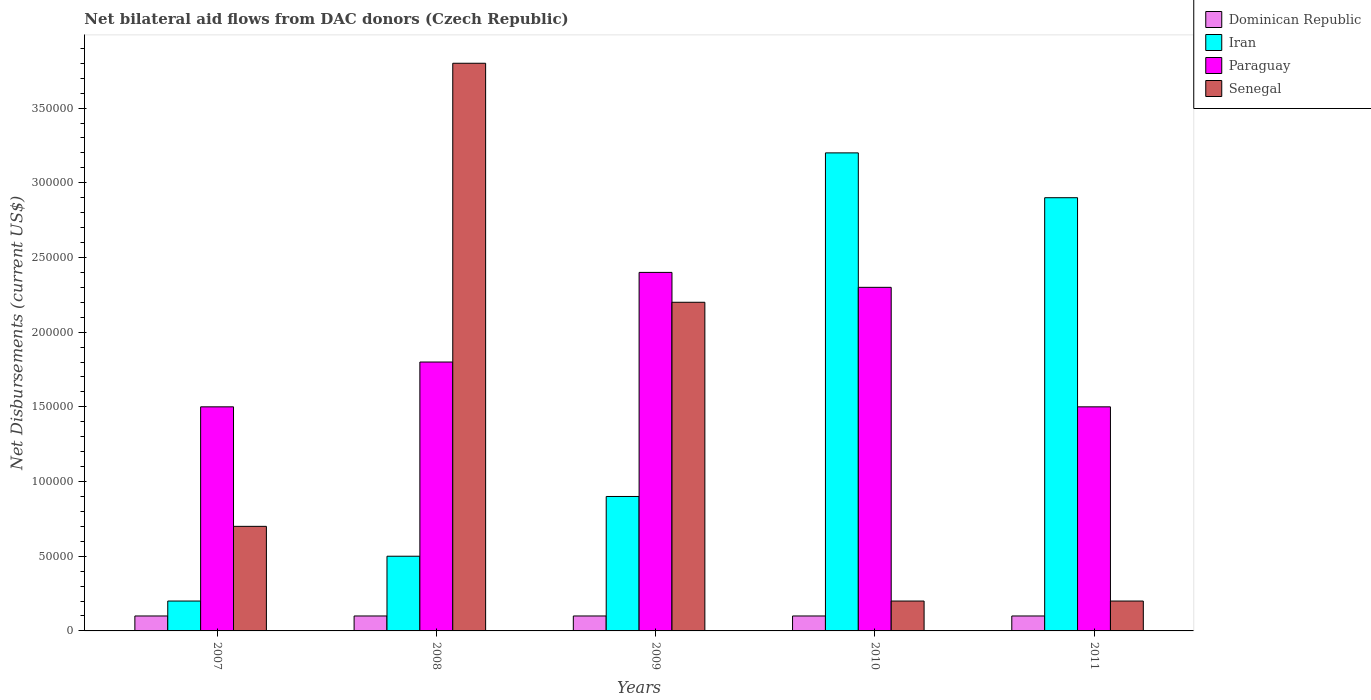How many groups of bars are there?
Your answer should be very brief. 5. How many bars are there on the 4th tick from the left?
Your answer should be very brief. 4. What is the label of the 4th group of bars from the left?
Keep it short and to the point. 2010. What is the net bilateral aid flows in Paraguay in 2009?
Your response must be concise. 2.40e+05. Across all years, what is the maximum net bilateral aid flows in Paraguay?
Provide a short and direct response. 2.40e+05. Across all years, what is the minimum net bilateral aid flows in Paraguay?
Make the answer very short. 1.50e+05. In which year was the net bilateral aid flows in Paraguay minimum?
Your response must be concise. 2007. What is the total net bilateral aid flows in Iran in the graph?
Make the answer very short. 7.70e+05. What is the difference between the net bilateral aid flows in Paraguay in 2008 and that in 2010?
Offer a terse response. -5.00e+04. What is the difference between the net bilateral aid flows in Iran in 2008 and the net bilateral aid flows in Senegal in 2009?
Give a very brief answer. -1.70e+05. What is the average net bilateral aid flows in Paraguay per year?
Make the answer very short. 1.90e+05. In the year 2009, what is the difference between the net bilateral aid flows in Iran and net bilateral aid flows in Dominican Republic?
Your answer should be compact. 8.00e+04. What is the ratio of the net bilateral aid flows in Paraguay in 2007 to that in 2011?
Provide a succinct answer. 1. Is the net bilateral aid flows in Paraguay in 2008 less than that in 2009?
Ensure brevity in your answer.  Yes. Is the difference between the net bilateral aid flows in Iran in 2008 and 2011 greater than the difference between the net bilateral aid flows in Dominican Republic in 2008 and 2011?
Your response must be concise. No. What is the difference between the highest and the lowest net bilateral aid flows in Senegal?
Provide a succinct answer. 3.60e+05. Is it the case that in every year, the sum of the net bilateral aid flows in Iran and net bilateral aid flows in Dominican Republic is greater than the sum of net bilateral aid flows in Paraguay and net bilateral aid flows in Senegal?
Offer a very short reply. Yes. What does the 2nd bar from the left in 2011 represents?
Offer a terse response. Iran. What does the 2nd bar from the right in 2007 represents?
Your answer should be compact. Paraguay. Is it the case that in every year, the sum of the net bilateral aid flows in Senegal and net bilateral aid flows in Paraguay is greater than the net bilateral aid flows in Iran?
Give a very brief answer. No. How many bars are there?
Provide a short and direct response. 20. Are all the bars in the graph horizontal?
Ensure brevity in your answer.  No. What is the difference between two consecutive major ticks on the Y-axis?
Give a very brief answer. 5.00e+04. Does the graph contain any zero values?
Provide a succinct answer. No. Does the graph contain grids?
Offer a very short reply. No. Where does the legend appear in the graph?
Your response must be concise. Top right. How are the legend labels stacked?
Your answer should be very brief. Vertical. What is the title of the graph?
Your response must be concise. Net bilateral aid flows from DAC donors (Czech Republic). What is the label or title of the Y-axis?
Your response must be concise. Net Disbursements (current US$). What is the Net Disbursements (current US$) in Dominican Republic in 2007?
Keep it short and to the point. 10000. What is the Net Disbursements (current US$) of Paraguay in 2007?
Your answer should be compact. 1.50e+05. What is the Net Disbursements (current US$) in Senegal in 2007?
Offer a terse response. 7.00e+04. What is the Net Disbursements (current US$) in Iran in 2008?
Make the answer very short. 5.00e+04. What is the Net Disbursements (current US$) of Dominican Republic in 2009?
Offer a very short reply. 10000. What is the Net Disbursements (current US$) in Paraguay in 2009?
Offer a terse response. 2.40e+05. What is the Net Disbursements (current US$) of Senegal in 2009?
Give a very brief answer. 2.20e+05. What is the Net Disbursements (current US$) in Iran in 2010?
Your answer should be very brief. 3.20e+05. What is the Net Disbursements (current US$) in Paraguay in 2010?
Provide a short and direct response. 2.30e+05. What is the Net Disbursements (current US$) of Iran in 2011?
Offer a very short reply. 2.90e+05. What is the Net Disbursements (current US$) in Senegal in 2011?
Your answer should be very brief. 2.00e+04. Across all years, what is the maximum Net Disbursements (current US$) of Senegal?
Your answer should be very brief. 3.80e+05. Across all years, what is the minimum Net Disbursements (current US$) in Iran?
Ensure brevity in your answer.  2.00e+04. Across all years, what is the minimum Net Disbursements (current US$) in Paraguay?
Your answer should be very brief. 1.50e+05. What is the total Net Disbursements (current US$) of Iran in the graph?
Provide a succinct answer. 7.70e+05. What is the total Net Disbursements (current US$) in Paraguay in the graph?
Provide a succinct answer. 9.50e+05. What is the total Net Disbursements (current US$) of Senegal in the graph?
Offer a terse response. 7.10e+05. What is the difference between the Net Disbursements (current US$) of Dominican Republic in 2007 and that in 2008?
Keep it short and to the point. 0. What is the difference between the Net Disbursements (current US$) in Senegal in 2007 and that in 2008?
Your answer should be compact. -3.10e+05. What is the difference between the Net Disbursements (current US$) of Iran in 2007 and that in 2009?
Your answer should be compact. -7.00e+04. What is the difference between the Net Disbursements (current US$) of Paraguay in 2007 and that in 2009?
Your answer should be very brief. -9.00e+04. What is the difference between the Net Disbursements (current US$) in Senegal in 2007 and that in 2009?
Your answer should be compact. -1.50e+05. What is the difference between the Net Disbursements (current US$) in Iran in 2007 and that in 2010?
Your response must be concise. -3.00e+05. What is the difference between the Net Disbursements (current US$) in Dominican Republic in 2007 and that in 2011?
Give a very brief answer. 0. What is the difference between the Net Disbursements (current US$) of Iran in 2008 and that in 2009?
Give a very brief answer. -4.00e+04. What is the difference between the Net Disbursements (current US$) of Paraguay in 2008 and that in 2009?
Ensure brevity in your answer.  -6.00e+04. What is the difference between the Net Disbursements (current US$) in Senegal in 2008 and that in 2009?
Your answer should be compact. 1.60e+05. What is the difference between the Net Disbursements (current US$) in Iran in 2008 and that in 2010?
Provide a succinct answer. -2.70e+05. What is the difference between the Net Disbursements (current US$) in Senegal in 2008 and that in 2011?
Keep it short and to the point. 3.60e+05. What is the difference between the Net Disbursements (current US$) in Iran in 2009 and that in 2010?
Ensure brevity in your answer.  -2.30e+05. What is the difference between the Net Disbursements (current US$) in Dominican Republic in 2009 and that in 2011?
Ensure brevity in your answer.  0. What is the difference between the Net Disbursements (current US$) in Iran in 2009 and that in 2011?
Offer a terse response. -2.00e+05. What is the difference between the Net Disbursements (current US$) in Paraguay in 2009 and that in 2011?
Offer a terse response. 9.00e+04. What is the difference between the Net Disbursements (current US$) of Senegal in 2009 and that in 2011?
Ensure brevity in your answer.  2.00e+05. What is the difference between the Net Disbursements (current US$) in Dominican Republic in 2010 and that in 2011?
Make the answer very short. 0. What is the difference between the Net Disbursements (current US$) in Iran in 2010 and that in 2011?
Ensure brevity in your answer.  3.00e+04. What is the difference between the Net Disbursements (current US$) in Dominican Republic in 2007 and the Net Disbursements (current US$) in Paraguay in 2008?
Offer a terse response. -1.70e+05. What is the difference between the Net Disbursements (current US$) of Dominican Republic in 2007 and the Net Disbursements (current US$) of Senegal in 2008?
Make the answer very short. -3.70e+05. What is the difference between the Net Disbursements (current US$) in Iran in 2007 and the Net Disbursements (current US$) in Senegal in 2008?
Your answer should be very brief. -3.60e+05. What is the difference between the Net Disbursements (current US$) of Dominican Republic in 2007 and the Net Disbursements (current US$) of Iran in 2009?
Offer a terse response. -8.00e+04. What is the difference between the Net Disbursements (current US$) of Dominican Republic in 2007 and the Net Disbursements (current US$) of Paraguay in 2009?
Give a very brief answer. -2.30e+05. What is the difference between the Net Disbursements (current US$) of Dominican Republic in 2007 and the Net Disbursements (current US$) of Senegal in 2009?
Offer a terse response. -2.10e+05. What is the difference between the Net Disbursements (current US$) in Iran in 2007 and the Net Disbursements (current US$) in Senegal in 2009?
Your response must be concise. -2.00e+05. What is the difference between the Net Disbursements (current US$) of Paraguay in 2007 and the Net Disbursements (current US$) of Senegal in 2009?
Give a very brief answer. -7.00e+04. What is the difference between the Net Disbursements (current US$) in Dominican Republic in 2007 and the Net Disbursements (current US$) in Iran in 2010?
Your answer should be compact. -3.10e+05. What is the difference between the Net Disbursements (current US$) of Dominican Republic in 2007 and the Net Disbursements (current US$) of Paraguay in 2010?
Keep it short and to the point. -2.20e+05. What is the difference between the Net Disbursements (current US$) in Iran in 2007 and the Net Disbursements (current US$) in Senegal in 2010?
Provide a succinct answer. 0. What is the difference between the Net Disbursements (current US$) in Paraguay in 2007 and the Net Disbursements (current US$) in Senegal in 2010?
Your answer should be very brief. 1.30e+05. What is the difference between the Net Disbursements (current US$) of Dominican Republic in 2007 and the Net Disbursements (current US$) of Iran in 2011?
Ensure brevity in your answer.  -2.80e+05. What is the difference between the Net Disbursements (current US$) in Dominican Republic in 2007 and the Net Disbursements (current US$) in Paraguay in 2011?
Make the answer very short. -1.40e+05. What is the difference between the Net Disbursements (current US$) in Dominican Republic in 2007 and the Net Disbursements (current US$) in Senegal in 2011?
Give a very brief answer. -10000. What is the difference between the Net Disbursements (current US$) of Iran in 2007 and the Net Disbursements (current US$) of Paraguay in 2011?
Give a very brief answer. -1.30e+05. What is the difference between the Net Disbursements (current US$) in Paraguay in 2007 and the Net Disbursements (current US$) in Senegal in 2011?
Your answer should be very brief. 1.30e+05. What is the difference between the Net Disbursements (current US$) in Dominican Republic in 2008 and the Net Disbursements (current US$) in Iran in 2009?
Your answer should be compact. -8.00e+04. What is the difference between the Net Disbursements (current US$) in Dominican Republic in 2008 and the Net Disbursements (current US$) in Senegal in 2009?
Your answer should be very brief. -2.10e+05. What is the difference between the Net Disbursements (current US$) in Iran in 2008 and the Net Disbursements (current US$) in Paraguay in 2009?
Your answer should be compact. -1.90e+05. What is the difference between the Net Disbursements (current US$) in Dominican Republic in 2008 and the Net Disbursements (current US$) in Iran in 2010?
Ensure brevity in your answer.  -3.10e+05. What is the difference between the Net Disbursements (current US$) of Dominican Republic in 2008 and the Net Disbursements (current US$) of Paraguay in 2010?
Keep it short and to the point. -2.20e+05. What is the difference between the Net Disbursements (current US$) of Dominican Republic in 2008 and the Net Disbursements (current US$) of Senegal in 2010?
Provide a succinct answer. -10000. What is the difference between the Net Disbursements (current US$) in Iran in 2008 and the Net Disbursements (current US$) in Paraguay in 2010?
Your response must be concise. -1.80e+05. What is the difference between the Net Disbursements (current US$) in Paraguay in 2008 and the Net Disbursements (current US$) in Senegal in 2010?
Provide a succinct answer. 1.60e+05. What is the difference between the Net Disbursements (current US$) of Dominican Republic in 2008 and the Net Disbursements (current US$) of Iran in 2011?
Your answer should be compact. -2.80e+05. What is the difference between the Net Disbursements (current US$) of Dominican Republic in 2008 and the Net Disbursements (current US$) of Paraguay in 2011?
Provide a succinct answer. -1.40e+05. What is the difference between the Net Disbursements (current US$) of Iran in 2008 and the Net Disbursements (current US$) of Paraguay in 2011?
Give a very brief answer. -1.00e+05. What is the difference between the Net Disbursements (current US$) of Iran in 2008 and the Net Disbursements (current US$) of Senegal in 2011?
Ensure brevity in your answer.  3.00e+04. What is the difference between the Net Disbursements (current US$) in Paraguay in 2008 and the Net Disbursements (current US$) in Senegal in 2011?
Ensure brevity in your answer.  1.60e+05. What is the difference between the Net Disbursements (current US$) in Dominican Republic in 2009 and the Net Disbursements (current US$) in Iran in 2010?
Your answer should be compact. -3.10e+05. What is the difference between the Net Disbursements (current US$) of Dominican Republic in 2009 and the Net Disbursements (current US$) of Paraguay in 2010?
Ensure brevity in your answer.  -2.20e+05. What is the difference between the Net Disbursements (current US$) in Dominican Republic in 2009 and the Net Disbursements (current US$) in Senegal in 2010?
Your answer should be very brief. -10000. What is the difference between the Net Disbursements (current US$) in Iran in 2009 and the Net Disbursements (current US$) in Senegal in 2010?
Your answer should be compact. 7.00e+04. What is the difference between the Net Disbursements (current US$) in Dominican Republic in 2009 and the Net Disbursements (current US$) in Iran in 2011?
Provide a short and direct response. -2.80e+05. What is the difference between the Net Disbursements (current US$) in Dominican Republic in 2009 and the Net Disbursements (current US$) in Paraguay in 2011?
Make the answer very short. -1.40e+05. What is the difference between the Net Disbursements (current US$) in Dominican Republic in 2009 and the Net Disbursements (current US$) in Senegal in 2011?
Ensure brevity in your answer.  -10000. What is the difference between the Net Disbursements (current US$) in Iran in 2009 and the Net Disbursements (current US$) in Senegal in 2011?
Offer a very short reply. 7.00e+04. What is the difference between the Net Disbursements (current US$) of Paraguay in 2009 and the Net Disbursements (current US$) of Senegal in 2011?
Offer a very short reply. 2.20e+05. What is the difference between the Net Disbursements (current US$) of Dominican Republic in 2010 and the Net Disbursements (current US$) of Iran in 2011?
Keep it short and to the point. -2.80e+05. What is the difference between the Net Disbursements (current US$) of Dominican Republic in 2010 and the Net Disbursements (current US$) of Senegal in 2011?
Keep it short and to the point. -10000. What is the difference between the Net Disbursements (current US$) of Iran in 2010 and the Net Disbursements (current US$) of Paraguay in 2011?
Your response must be concise. 1.70e+05. What is the difference between the Net Disbursements (current US$) of Paraguay in 2010 and the Net Disbursements (current US$) of Senegal in 2011?
Offer a terse response. 2.10e+05. What is the average Net Disbursements (current US$) of Dominican Republic per year?
Ensure brevity in your answer.  10000. What is the average Net Disbursements (current US$) in Iran per year?
Make the answer very short. 1.54e+05. What is the average Net Disbursements (current US$) in Paraguay per year?
Provide a short and direct response. 1.90e+05. What is the average Net Disbursements (current US$) in Senegal per year?
Ensure brevity in your answer.  1.42e+05. In the year 2007, what is the difference between the Net Disbursements (current US$) in Dominican Republic and Net Disbursements (current US$) in Iran?
Your response must be concise. -10000. In the year 2007, what is the difference between the Net Disbursements (current US$) of Dominican Republic and Net Disbursements (current US$) of Senegal?
Make the answer very short. -6.00e+04. In the year 2007, what is the difference between the Net Disbursements (current US$) of Iran and Net Disbursements (current US$) of Paraguay?
Provide a short and direct response. -1.30e+05. In the year 2007, what is the difference between the Net Disbursements (current US$) of Iran and Net Disbursements (current US$) of Senegal?
Your answer should be very brief. -5.00e+04. In the year 2008, what is the difference between the Net Disbursements (current US$) of Dominican Republic and Net Disbursements (current US$) of Paraguay?
Keep it short and to the point. -1.70e+05. In the year 2008, what is the difference between the Net Disbursements (current US$) of Dominican Republic and Net Disbursements (current US$) of Senegal?
Make the answer very short. -3.70e+05. In the year 2008, what is the difference between the Net Disbursements (current US$) in Iran and Net Disbursements (current US$) in Paraguay?
Provide a succinct answer. -1.30e+05. In the year 2008, what is the difference between the Net Disbursements (current US$) of Iran and Net Disbursements (current US$) of Senegal?
Provide a succinct answer. -3.30e+05. In the year 2008, what is the difference between the Net Disbursements (current US$) in Paraguay and Net Disbursements (current US$) in Senegal?
Give a very brief answer. -2.00e+05. In the year 2009, what is the difference between the Net Disbursements (current US$) in Dominican Republic and Net Disbursements (current US$) in Paraguay?
Give a very brief answer. -2.30e+05. In the year 2009, what is the difference between the Net Disbursements (current US$) in Iran and Net Disbursements (current US$) in Paraguay?
Offer a very short reply. -1.50e+05. In the year 2009, what is the difference between the Net Disbursements (current US$) in Iran and Net Disbursements (current US$) in Senegal?
Your answer should be compact. -1.30e+05. In the year 2009, what is the difference between the Net Disbursements (current US$) of Paraguay and Net Disbursements (current US$) of Senegal?
Offer a very short reply. 2.00e+04. In the year 2010, what is the difference between the Net Disbursements (current US$) in Dominican Republic and Net Disbursements (current US$) in Iran?
Ensure brevity in your answer.  -3.10e+05. In the year 2010, what is the difference between the Net Disbursements (current US$) of Dominican Republic and Net Disbursements (current US$) of Paraguay?
Keep it short and to the point. -2.20e+05. In the year 2010, what is the difference between the Net Disbursements (current US$) in Dominican Republic and Net Disbursements (current US$) in Senegal?
Ensure brevity in your answer.  -10000. In the year 2010, what is the difference between the Net Disbursements (current US$) in Iran and Net Disbursements (current US$) in Senegal?
Ensure brevity in your answer.  3.00e+05. In the year 2010, what is the difference between the Net Disbursements (current US$) of Paraguay and Net Disbursements (current US$) of Senegal?
Your answer should be compact. 2.10e+05. In the year 2011, what is the difference between the Net Disbursements (current US$) of Dominican Republic and Net Disbursements (current US$) of Iran?
Your response must be concise. -2.80e+05. In the year 2011, what is the difference between the Net Disbursements (current US$) in Dominican Republic and Net Disbursements (current US$) in Senegal?
Give a very brief answer. -10000. In the year 2011, what is the difference between the Net Disbursements (current US$) of Iran and Net Disbursements (current US$) of Paraguay?
Your answer should be very brief. 1.40e+05. In the year 2011, what is the difference between the Net Disbursements (current US$) of Iran and Net Disbursements (current US$) of Senegal?
Provide a succinct answer. 2.70e+05. In the year 2011, what is the difference between the Net Disbursements (current US$) in Paraguay and Net Disbursements (current US$) in Senegal?
Keep it short and to the point. 1.30e+05. What is the ratio of the Net Disbursements (current US$) of Paraguay in 2007 to that in 2008?
Make the answer very short. 0.83. What is the ratio of the Net Disbursements (current US$) in Senegal in 2007 to that in 2008?
Provide a short and direct response. 0.18. What is the ratio of the Net Disbursements (current US$) of Dominican Republic in 2007 to that in 2009?
Keep it short and to the point. 1. What is the ratio of the Net Disbursements (current US$) in Iran in 2007 to that in 2009?
Make the answer very short. 0.22. What is the ratio of the Net Disbursements (current US$) of Senegal in 2007 to that in 2009?
Your response must be concise. 0.32. What is the ratio of the Net Disbursements (current US$) in Iran in 2007 to that in 2010?
Offer a terse response. 0.06. What is the ratio of the Net Disbursements (current US$) in Paraguay in 2007 to that in 2010?
Offer a terse response. 0.65. What is the ratio of the Net Disbursements (current US$) of Dominican Republic in 2007 to that in 2011?
Your answer should be very brief. 1. What is the ratio of the Net Disbursements (current US$) in Iran in 2007 to that in 2011?
Your answer should be very brief. 0.07. What is the ratio of the Net Disbursements (current US$) in Paraguay in 2007 to that in 2011?
Your response must be concise. 1. What is the ratio of the Net Disbursements (current US$) in Dominican Republic in 2008 to that in 2009?
Your response must be concise. 1. What is the ratio of the Net Disbursements (current US$) in Iran in 2008 to that in 2009?
Your response must be concise. 0.56. What is the ratio of the Net Disbursements (current US$) of Paraguay in 2008 to that in 2009?
Offer a terse response. 0.75. What is the ratio of the Net Disbursements (current US$) in Senegal in 2008 to that in 2009?
Your response must be concise. 1.73. What is the ratio of the Net Disbursements (current US$) in Dominican Republic in 2008 to that in 2010?
Give a very brief answer. 1. What is the ratio of the Net Disbursements (current US$) of Iran in 2008 to that in 2010?
Offer a terse response. 0.16. What is the ratio of the Net Disbursements (current US$) in Paraguay in 2008 to that in 2010?
Provide a short and direct response. 0.78. What is the ratio of the Net Disbursements (current US$) of Senegal in 2008 to that in 2010?
Provide a short and direct response. 19. What is the ratio of the Net Disbursements (current US$) in Iran in 2008 to that in 2011?
Your answer should be compact. 0.17. What is the ratio of the Net Disbursements (current US$) in Iran in 2009 to that in 2010?
Your response must be concise. 0.28. What is the ratio of the Net Disbursements (current US$) of Paraguay in 2009 to that in 2010?
Your response must be concise. 1.04. What is the ratio of the Net Disbursements (current US$) in Senegal in 2009 to that in 2010?
Provide a succinct answer. 11. What is the ratio of the Net Disbursements (current US$) in Dominican Republic in 2009 to that in 2011?
Your answer should be compact. 1. What is the ratio of the Net Disbursements (current US$) of Iran in 2009 to that in 2011?
Provide a succinct answer. 0.31. What is the ratio of the Net Disbursements (current US$) of Iran in 2010 to that in 2011?
Keep it short and to the point. 1.1. What is the ratio of the Net Disbursements (current US$) in Paraguay in 2010 to that in 2011?
Offer a very short reply. 1.53. What is the ratio of the Net Disbursements (current US$) of Senegal in 2010 to that in 2011?
Provide a short and direct response. 1. What is the difference between the highest and the second highest Net Disbursements (current US$) in Paraguay?
Provide a short and direct response. 10000. What is the difference between the highest and the second highest Net Disbursements (current US$) in Senegal?
Offer a terse response. 1.60e+05. 